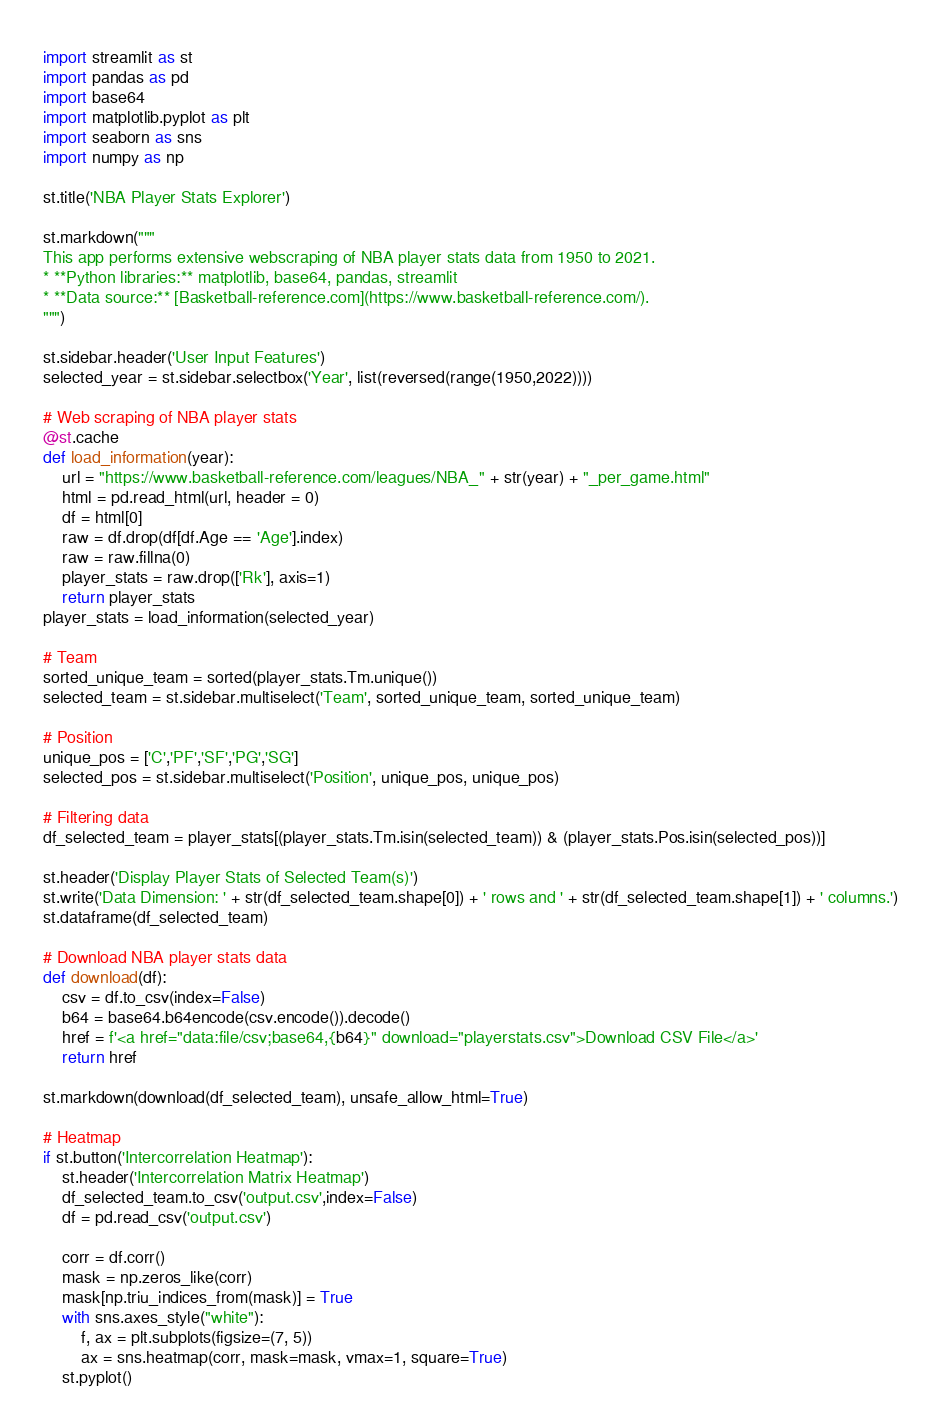<code> <loc_0><loc_0><loc_500><loc_500><_Python_>import streamlit as st
import pandas as pd
import base64
import matplotlib.pyplot as plt
import seaborn as sns
import numpy as np

st.title('NBA Player Stats Explorer')

st.markdown("""
This app performs extensive webscraping of NBA player stats data from 1950 to 2021.
* **Python libraries:** matplotlib, base64, pandas, streamlit
* **Data source:** [Basketball-reference.com](https://www.basketball-reference.com/).
""")

st.sidebar.header('User Input Features')
selected_year = st.sidebar.selectbox('Year', list(reversed(range(1950,2022))))

# Web scraping of NBA player stats
@st.cache
def load_information(year):
    url = "https://www.basketball-reference.com/leagues/NBA_" + str(year) + "_per_game.html"
    html = pd.read_html(url, header = 0)
    df = html[0]
    raw = df.drop(df[df.Age == 'Age'].index)
    raw = raw.fillna(0)
    player_stats = raw.drop(['Rk'], axis=1)
    return player_stats
player_stats = load_information(selected_year)

# Team
sorted_unique_team = sorted(player_stats.Tm.unique())
selected_team = st.sidebar.multiselect('Team', sorted_unique_team, sorted_unique_team)

# Position
unique_pos = ['C','PF','SF','PG','SG']
selected_pos = st.sidebar.multiselect('Position', unique_pos, unique_pos)

# Filtering data
df_selected_team = player_stats[(player_stats.Tm.isin(selected_team)) & (player_stats.Pos.isin(selected_pos))]

st.header('Display Player Stats of Selected Team(s)')
st.write('Data Dimension: ' + str(df_selected_team.shape[0]) + ' rows and ' + str(df_selected_team.shape[1]) + ' columns.')
st.dataframe(df_selected_team)

# Download NBA player stats data
def download(df):
    csv = df.to_csv(index=False)
    b64 = base64.b64encode(csv.encode()).decode()
    href = f'<a href="data:file/csv;base64,{b64}" download="playerstats.csv">Download CSV File</a>'
    return href

st.markdown(download(df_selected_team), unsafe_allow_html=True)

# Heatmap
if st.button('Intercorrelation Heatmap'):
    st.header('Intercorrelation Matrix Heatmap')
    df_selected_team.to_csv('output.csv',index=False)
    df = pd.read_csv('output.csv')

    corr = df.corr()
    mask = np.zeros_like(corr)
    mask[np.triu_indices_from(mask)] = True
    with sns.axes_style("white"):
        f, ax = plt.subplots(figsize=(7, 5))
        ax = sns.heatmap(corr, mask=mask, vmax=1, square=True)
    st.pyplot()
</code> 